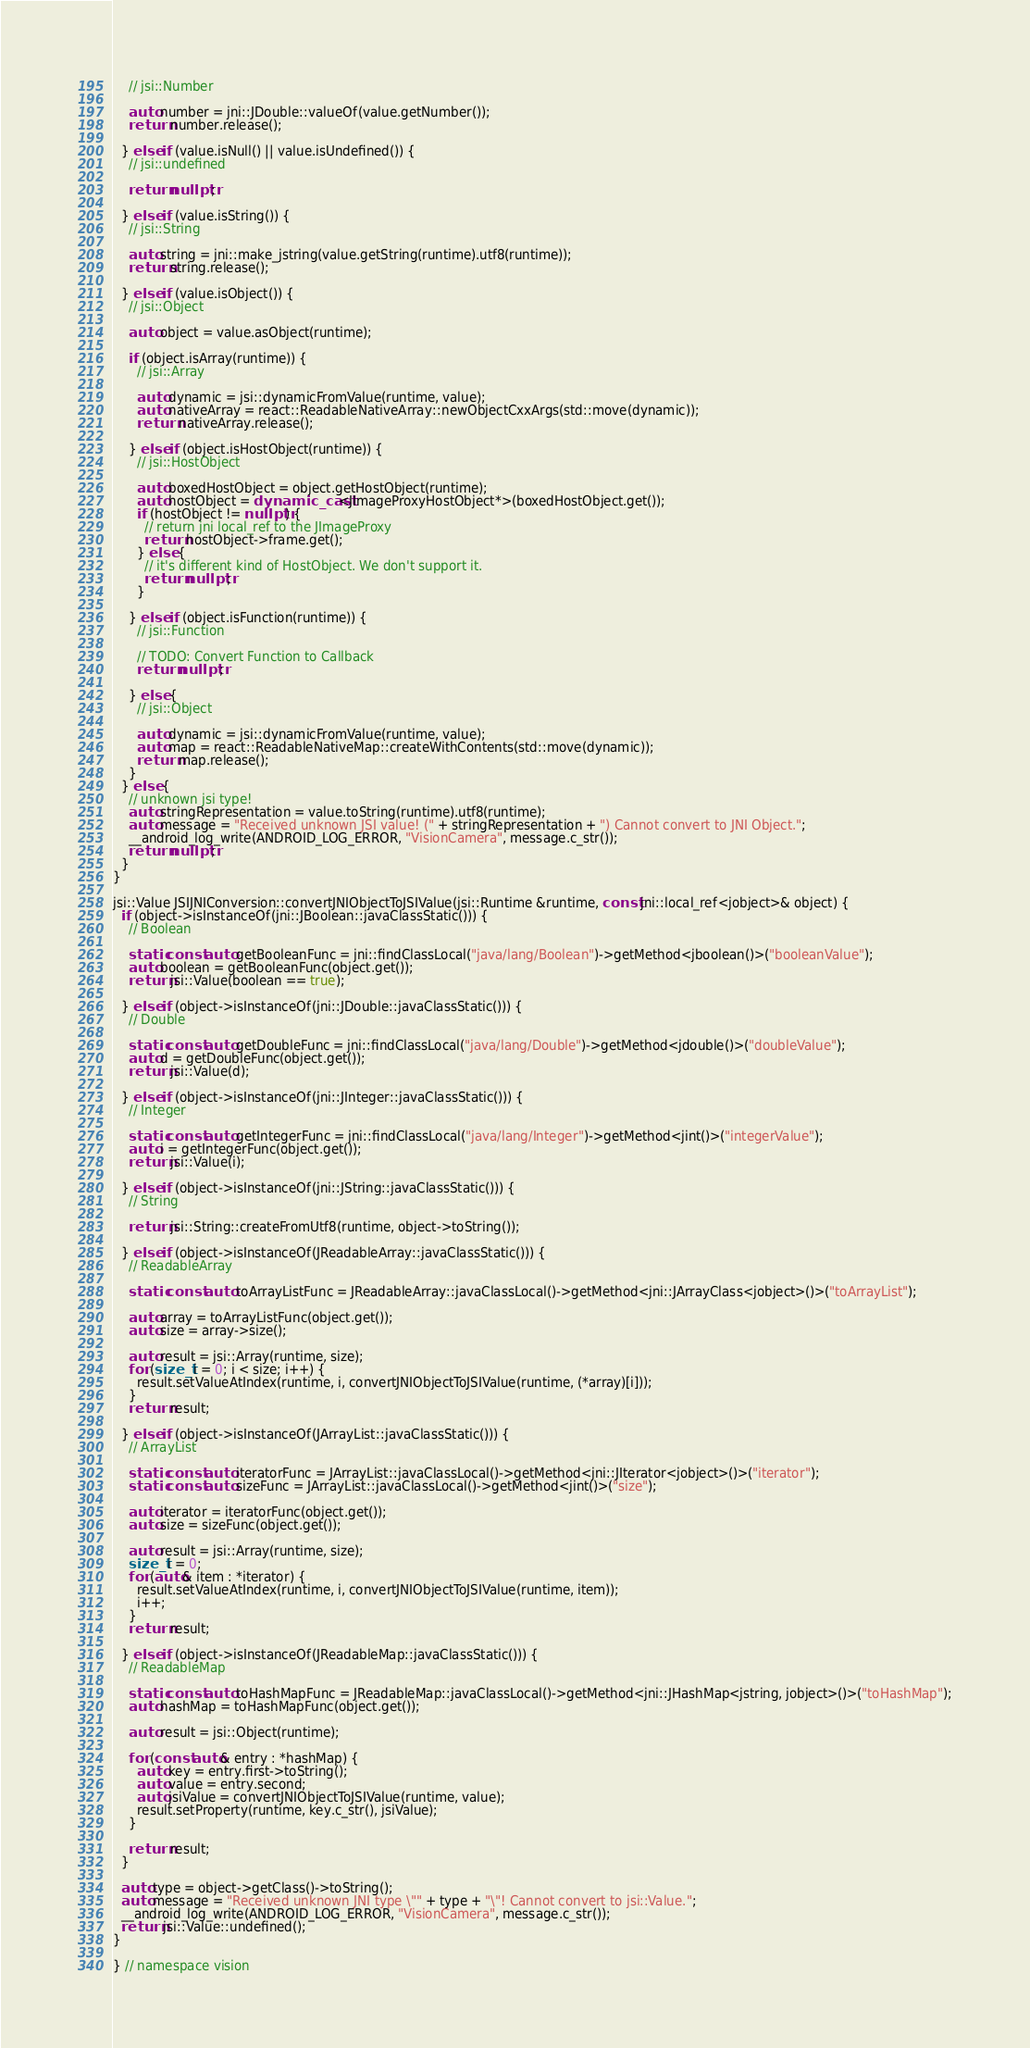<code> <loc_0><loc_0><loc_500><loc_500><_C++_>    // jsi::Number

    auto number = jni::JDouble::valueOf(value.getNumber());
    return number.release();

  } else if (value.isNull() || value.isUndefined()) {
    // jsi::undefined

    return nullptr;

  } else if (value.isString()) {
    // jsi::String

    auto string = jni::make_jstring(value.getString(runtime).utf8(runtime));
    return string.release();

  } else if (value.isObject()) {
    // jsi::Object

    auto object = value.asObject(runtime);

    if (object.isArray(runtime)) {
      // jsi::Array

      auto dynamic = jsi::dynamicFromValue(runtime, value);
      auto nativeArray = react::ReadableNativeArray::newObjectCxxArgs(std::move(dynamic));
      return nativeArray.release();

    } else if (object.isHostObject(runtime)) {
      // jsi::HostObject

      auto boxedHostObject = object.getHostObject(runtime);
      auto hostObject = dynamic_cast<JImageProxyHostObject*>(boxedHostObject.get());
      if (hostObject != nullptr) {
        // return jni local_ref to the JImageProxy
        return hostObject->frame.get();
      } else {
        // it's different kind of HostObject. We don't support it.
        return nullptr;
      }

    } else if (object.isFunction(runtime)) {
      // jsi::Function

      // TODO: Convert Function to Callback
      return nullptr;

    } else {
      // jsi::Object

      auto dynamic = jsi::dynamicFromValue(runtime, value);
      auto map = react::ReadableNativeMap::createWithContents(std::move(dynamic));
      return map.release();
    }
  } else {
    // unknown jsi type!
    auto stringRepresentation = value.toString(runtime).utf8(runtime);
    auto message = "Received unknown JSI value! (" + stringRepresentation + ") Cannot convert to JNI Object.";
    __android_log_write(ANDROID_LOG_ERROR, "VisionCamera", message.c_str());
    return nullptr;
  }
}

jsi::Value JSIJNIConversion::convertJNIObjectToJSIValue(jsi::Runtime &runtime, const jni::local_ref<jobject>& object) {
  if (object->isInstanceOf(jni::JBoolean::javaClassStatic())) {
    // Boolean

    static const auto getBooleanFunc = jni::findClassLocal("java/lang/Boolean")->getMethod<jboolean()>("booleanValue");
    auto boolean = getBooleanFunc(object.get());
    return jsi::Value(boolean == true);

  } else if (object->isInstanceOf(jni::JDouble::javaClassStatic())) {
    // Double

    static const auto getDoubleFunc = jni::findClassLocal("java/lang/Double")->getMethod<jdouble()>("doubleValue");
    auto d = getDoubleFunc(object.get());
    return jsi::Value(d);

  } else if (object->isInstanceOf(jni::JInteger::javaClassStatic())) {
    // Integer

    static const auto getIntegerFunc = jni::findClassLocal("java/lang/Integer")->getMethod<jint()>("integerValue");
    auto i = getIntegerFunc(object.get());
    return jsi::Value(i);

  } else if (object->isInstanceOf(jni::JString::javaClassStatic())) {
    // String

    return jsi::String::createFromUtf8(runtime, object->toString());

  } else if (object->isInstanceOf(JReadableArray::javaClassStatic())) {
    // ReadableArray

    static const auto toArrayListFunc = JReadableArray::javaClassLocal()->getMethod<jni::JArrayClass<jobject>()>("toArrayList");

    auto array = toArrayListFunc(object.get());
    auto size = array->size();

    auto result = jsi::Array(runtime, size);
    for (size_t i = 0; i < size; i++) {
      result.setValueAtIndex(runtime, i, convertJNIObjectToJSIValue(runtime, (*array)[i]));
    }
    return result;

  } else if (object->isInstanceOf(JArrayList::javaClassStatic())) {
    // ArrayList

    static const auto iteratorFunc = JArrayList::javaClassLocal()->getMethod<jni::JIterator<jobject>()>("iterator");
    static const auto sizeFunc = JArrayList::javaClassLocal()->getMethod<jint()>("size");

    auto iterator = iteratorFunc(object.get());
    auto size = sizeFunc(object.get());

    auto result = jsi::Array(runtime, size);
    size_t i = 0;
    for (auto& item : *iterator) {
      result.setValueAtIndex(runtime, i, convertJNIObjectToJSIValue(runtime, item));
      i++;
    }
    return result;

  } else if (object->isInstanceOf(JReadableMap::javaClassStatic())) {
    // ReadableMap

    static const auto toHashMapFunc = JReadableMap::javaClassLocal()->getMethod<jni::JHashMap<jstring, jobject>()>("toHashMap");
    auto hashMap = toHashMapFunc(object.get());

    auto result = jsi::Object(runtime);

    for (const auto& entry : *hashMap) {
      auto key = entry.first->toString();
      auto value = entry.second;
      auto jsiValue = convertJNIObjectToJSIValue(runtime, value);
      result.setProperty(runtime, key.c_str(), jsiValue);
    }

    return result;
  }

  auto type = object->getClass()->toString();
  auto message = "Received unknown JNI type \"" + type + "\"! Cannot convert to jsi::Value.";
  __android_log_write(ANDROID_LOG_ERROR, "VisionCamera", message.c_str());
  return jsi::Value::undefined();
}

} // namespace vision
</code> 